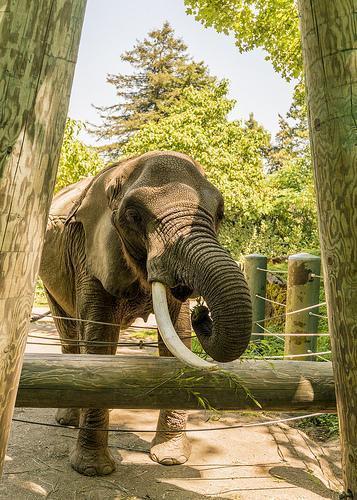How many elephants in the photo?
Give a very brief answer. 1. 